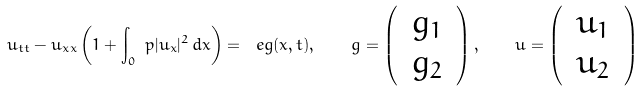<formula> <loc_0><loc_0><loc_500><loc_500>u _ { t t } - u _ { x x } \left ( 1 + \int _ { 0 } ^ { \ } p | u _ { x } | ^ { 2 } \, d x \right ) = \ e g ( x , t ) , \quad g = \left ( \begin{array} { c } \, g _ { 1 } \, \\ \, g _ { 2 } \, \end{array} \right ) , \quad u = \left ( \begin{array} { c } \, u _ { 1 } \, \\ \, u _ { 2 } \, \end{array} \right )</formula> 